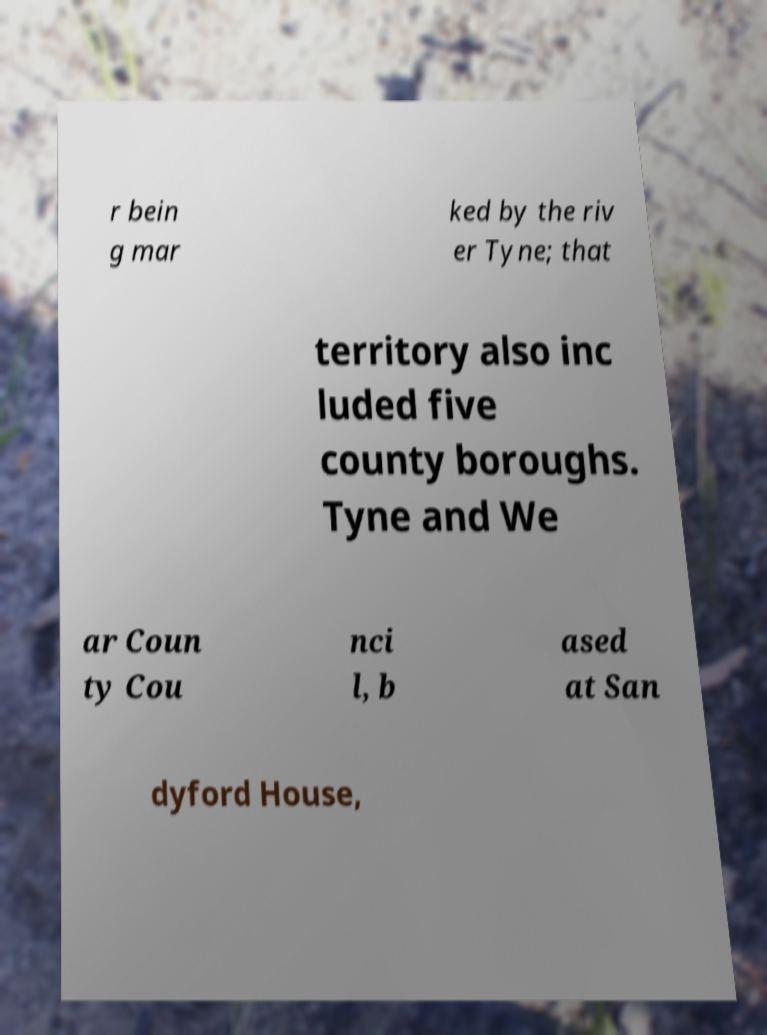What messages or text are displayed in this image? I need them in a readable, typed format. r bein g mar ked by the riv er Tyne; that territory also inc luded five county boroughs. Tyne and We ar Coun ty Cou nci l, b ased at San dyford House, 